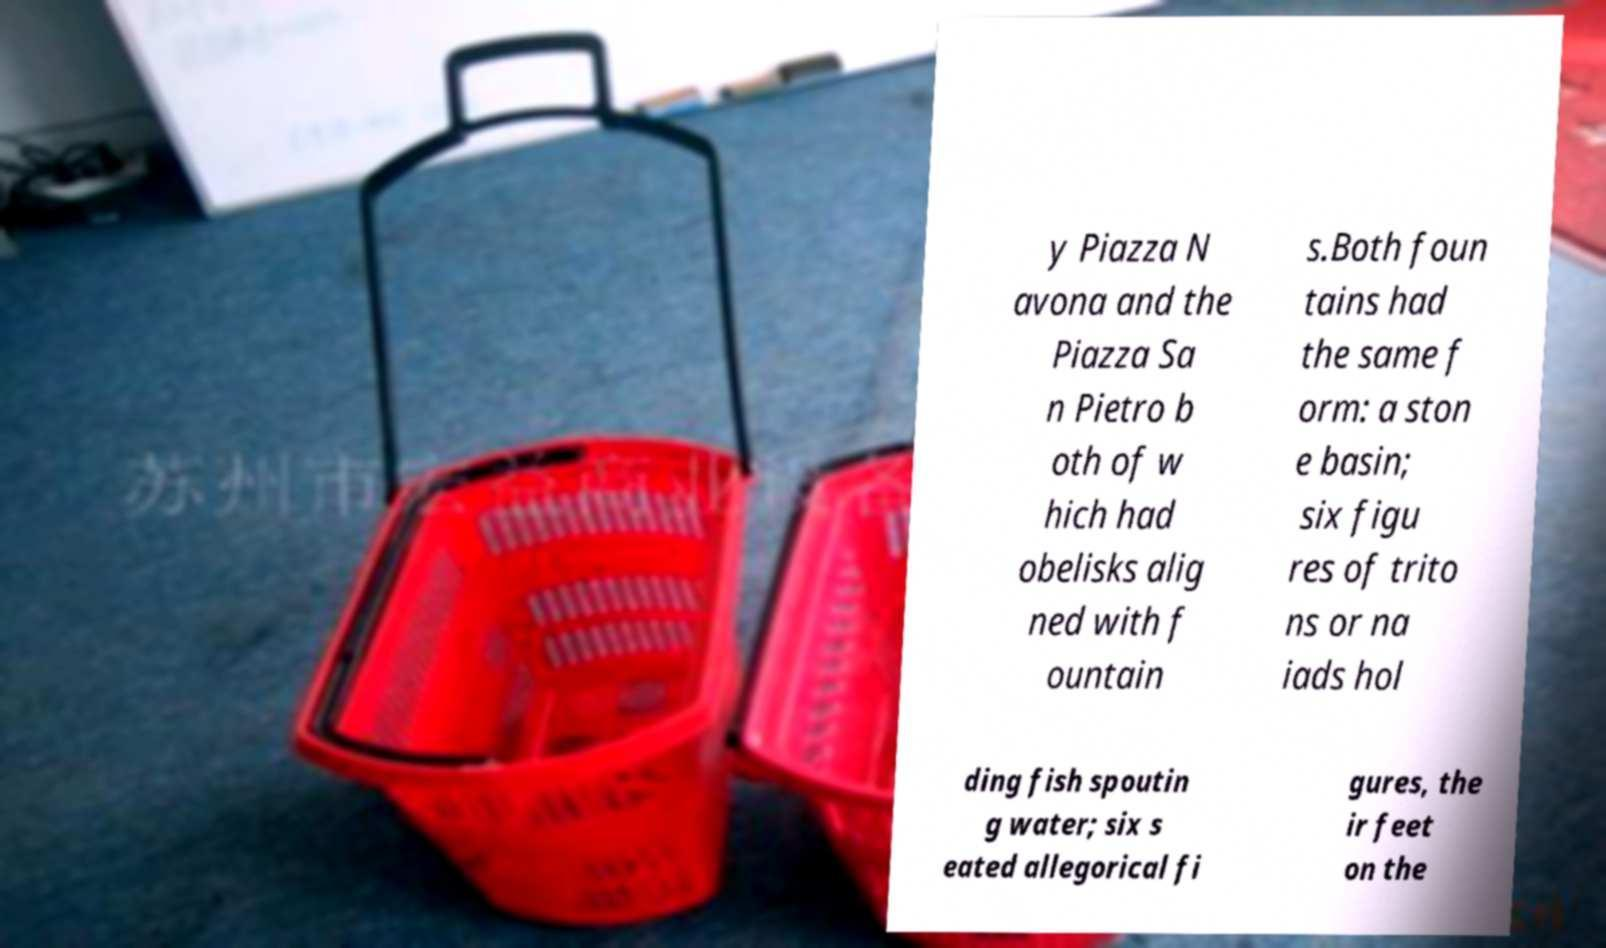For documentation purposes, I need the text within this image transcribed. Could you provide that? y Piazza N avona and the Piazza Sa n Pietro b oth of w hich had obelisks alig ned with f ountain s.Both foun tains had the same f orm: a ston e basin; six figu res of trito ns or na iads hol ding fish spoutin g water; six s eated allegorical fi gures, the ir feet on the 